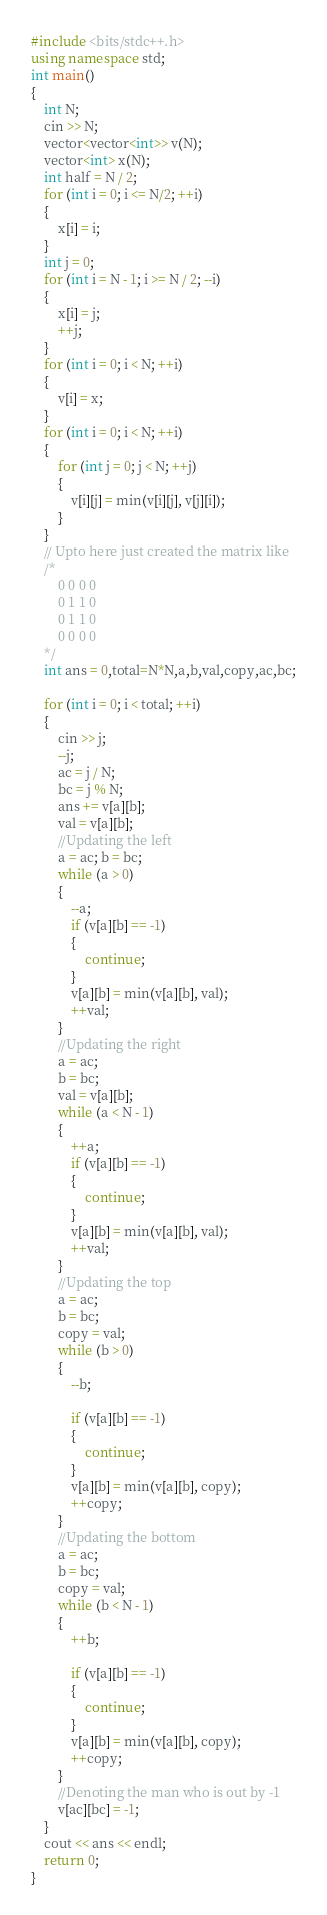<code> <loc_0><loc_0><loc_500><loc_500><_C++_>#include <bits/stdc++.h>
using namespace std;
int main()
{
	int N;
	cin >> N;
	vector<vector<int>> v(N);
	vector<int> x(N);
	int half = N / 2;
	for (int i = 0; i <= N/2; ++i)
	{
		x[i] = i;
	}
	int j = 0;
	for (int i = N - 1; i >= N / 2; --i)
	{
		x[i] = j;
		++j;
	}
	for (int i = 0; i < N; ++i)
	{
		v[i] = x;
	}
	for (int i = 0; i < N; ++i)
	{
		for (int j = 0; j < N; ++j)
		{
			v[i][j] = min(v[i][j], v[j][i]);
		}
	}
	// Upto here just created the matrix like
	/*
		0 0 0 0
		0 1 1 0
		0 1 1 0
		0 0 0 0
	*/
	int ans = 0,total=N*N,a,b,val,copy,ac,bc;

	for (int i = 0; i < total; ++i)
	{
		cin >> j;
		--j;
		ac = j / N;
		bc = j % N;
		ans += v[a][b];
		val = v[a][b];
		//Updating the left
		a = ac; b = bc;
		while (a > 0)
		{
			--a;
			if (v[a][b] == -1)
			{
				continue;
			}
			v[a][b] = min(v[a][b], val);
			++val;
		}
		//Updating the right
		a = ac;
		b = bc;
		val = v[a][b];
		while (a < N - 1)
		{
			++a;
			if (v[a][b] == -1)
			{
				continue;
			}
			v[a][b] = min(v[a][b], val);
			++val;
		}
		//Updating the top
		a = ac;
		b = bc;
		copy = val;
		while (b > 0)
		{
			--b;

			if (v[a][b] == -1)
			{
				continue;
			}
			v[a][b] = min(v[a][b], copy);
			++copy;
		}
		//Updating the bottom
		a = ac;
		b = bc;
		copy = val;
		while (b < N - 1)
		{
			++b;

			if (v[a][b] == -1)
			{
				continue;
			}
			v[a][b] = min(v[a][b], copy);
			++copy;
		}
		//Denoting the man who is out by -1
		v[ac][bc] = -1;
	}
	cout << ans << endl;
	return 0;
}</code> 